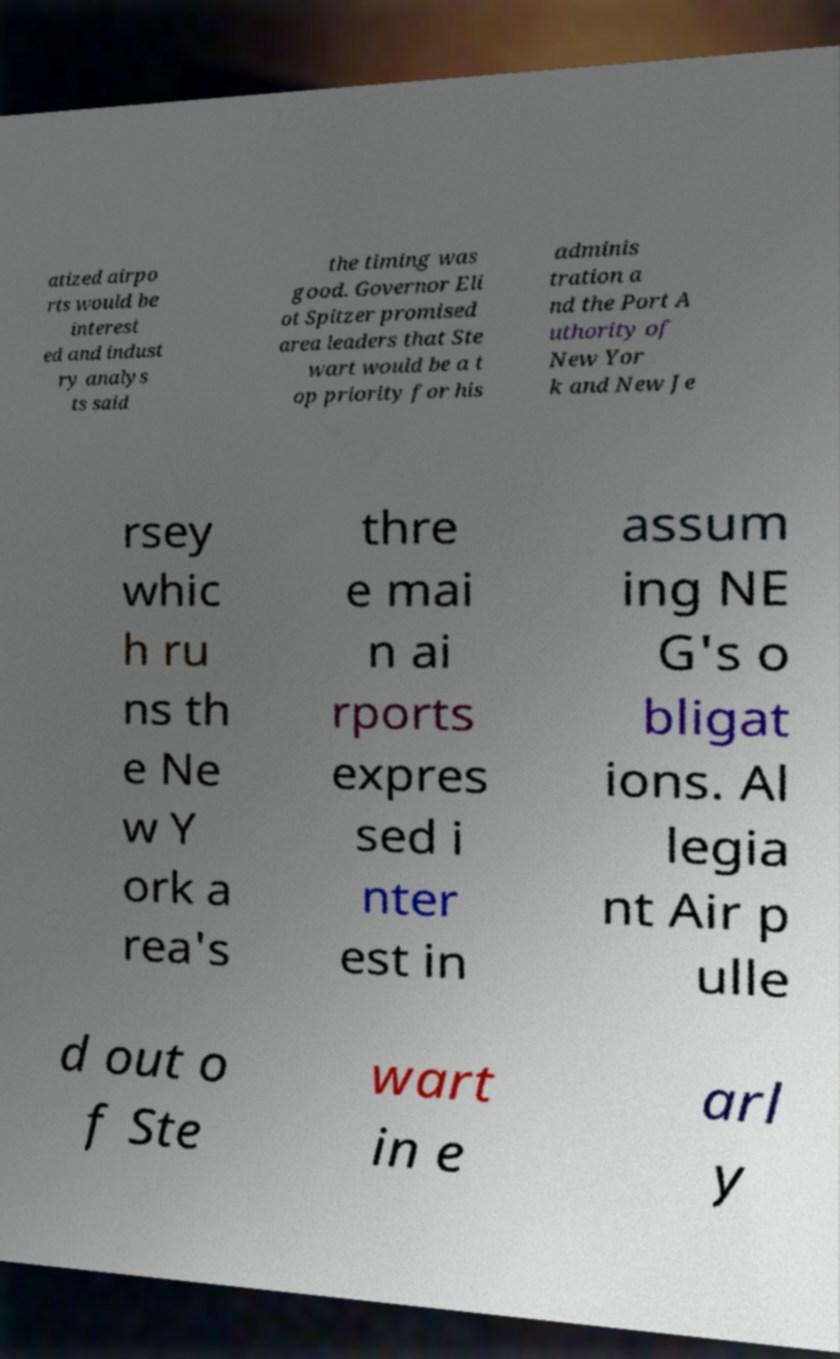There's text embedded in this image that I need extracted. Can you transcribe it verbatim? atized airpo rts would be interest ed and indust ry analys ts said the timing was good. Governor Eli ot Spitzer promised area leaders that Ste wart would be a t op priority for his adminis tration a nd the Port A uthority of New Yor k and New Je rsey whic h ru ns th e Ne w Y ork a rea's thre e mai n ai rports expres sed i nter est in assum ing NE G's o bligat ions. Al legia nt Air p ulle d out o f Ste wart in e arl y 